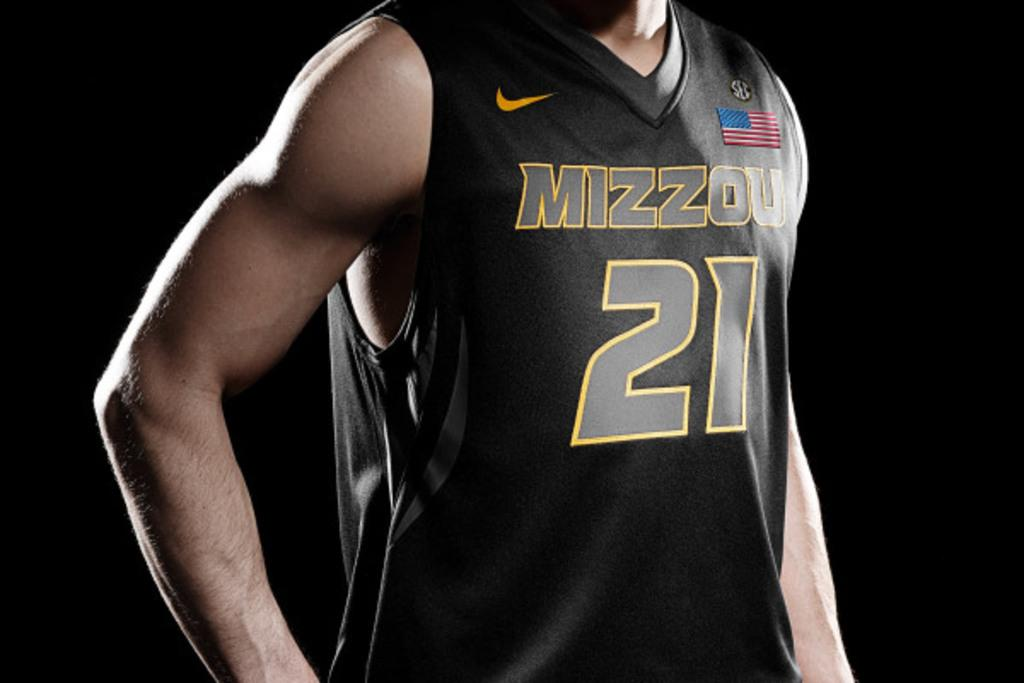Who or what is the main subject of the image? There is a person in the image. What is the person wearing? The person is wearing a black dress. Are there any unique features on the dress? Yes, there is text or writing on the dress. What is the color of the background in the image? The background of the image is black. How many beggars are visible in the image? There are no beggars present in the image; it features a person wearing a black dress with text or writing. What type of muscle is being flexed by the person in the image? There is no muscle being flexed in the image; the person is simply wearing a black dress with text or writing. 